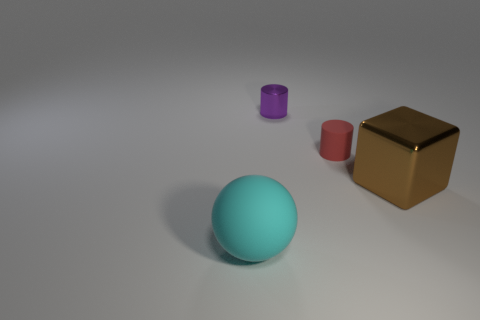Subtract all gray cylinders. Subtract all blue spheres. How many cylinders are left? 2 Add 1 big cyan shiny blocks. How many objects exist? 5 Subtract all spheres. How many objects are left? 3 Subtract 0 red balls. How many objects are left? 4 Subtract all yellow cubes. Subtract all tiny red cylinders. How many objects are left? 3 Add 2 small matte things. How many small matte things are left? 3 Add 4 metallic cubes. How many metallic cubes exist? 5 